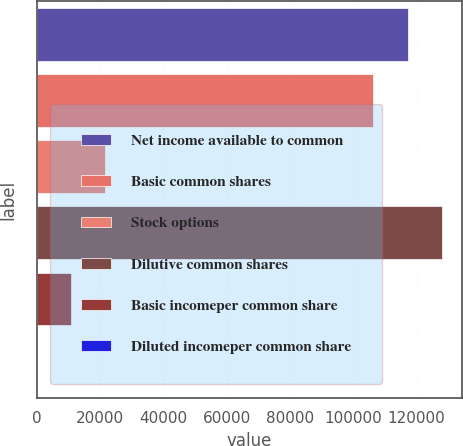Convert chart to OTSL. <chart><loc_0><loc_0><loc_500><loc_500><bar_chart><fcel>Net income available to common<fcel>Basic common shares<fcel>Stock options<fcel>Dilutive common shares<fcel>Basic incomeper common share<fcel>Diluted incomeper common share<nl><fcel>117157<fcel>106277<fcel>21761<fcel>128037<fcel>10881<fcel>0.98<nl></chart> 